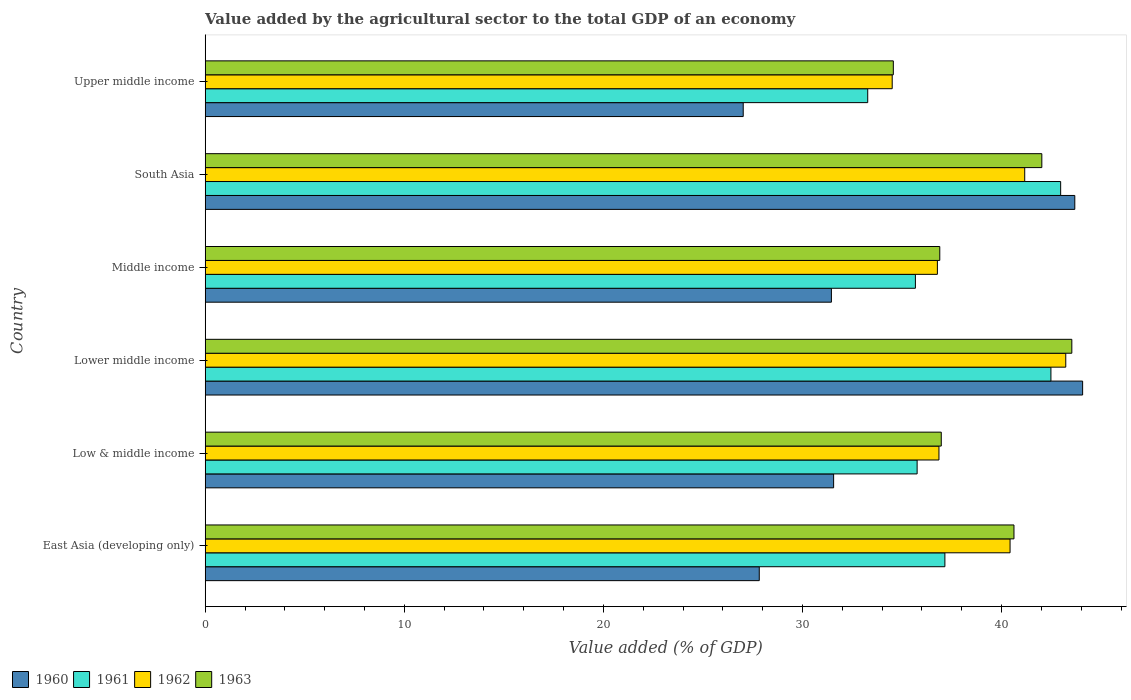How many groups of bars are there?
Ensure brevity in your answer.  6. Are the number of bars per tick equal to the number of legend labels?
Ensure brevity in your answer.  Yes. Are the number of bars on each tick of the Y-axis equal?
Provide a succinct answer. Yes. How many bars are there on the 5th tick from the top?
Make the answer very short. 4. How many bars are there on the 6th tick from the bottom?
Make the answer very short. 4. What is the label of the 3rd group of bars from the top?
Make the answer very short. Middle income. In how many cases, is the number of bars for a given country not equal to the number of legend labels?
Your response must be concise. 0. What is the value added by the agricultural sector to the total GDP in 1963 in Middle income?
Your answer should be compact. 36.89. Across all countries, what is the maximum value added by the agricultural sector to the total GDP in 1962?
Your answer should be compact. 43.22. Across all countries, what is the minimum value added by the agricultural sector to the total GDP in 1961?
Provide a short and direct response. 33.27. In which country was the value added by the agricultural sector to the total GDP in 1960 maximum?
Make the answer very short. Lower middle income. In which country was the value added by the agricultural sector to the total GDP in 1962 minimum?
Keep it short and to the point. Upper middle income. What is the total value added by the agricultural sector to the total GDP in 1962 in the graph?
Provide a succinct answer. 232.94. What is the difference between the value added by the agricultural sector to the total GDP in 1963 in Low & middle income and that in Lower middle income?
Provide a short and direct response. -6.56. What is the difference between the value added by the agricultural sector to the total GDP in 1961 in Upper middle income and the value added by the agricultural sector to the total GDP in 1960 in Low & middle income?
Give a very brief answer. 1.71. What is the average value added by the agricultural sector to the total GDP in 1963 per country?
Make the answer very short. 39.1. What is the difference between the value added by the agricultural sector to the total GDP in 1963 and value added by the agricultural sector to the total GDP in 1962 in Lower middle income?
Provide a short and direct response. 0.3. What is the ratio of the value added by the agricultural sector to the total GDP in 1962 in Low & middle income to that in Middle income?
Offer a very short reply. 1. Is the value added by the agricultural sector to the total GDP in 1960 in East Asia (developing only) less than that in Low & middle income?
Offer a very short reply. Yes. What is the difference between the highest and the second highest value added by the agricultural sector to the total GDP in 1962?
Give a very brief answer. 2.06. What is the difference between the highest and the lowest value added by the agricultural sector to the total GDP in 1961?
Offer a very short reply. 9.69. In how many countries, is the value added by the agricultural sector to the total GDP in 1961 greater than the average value added by the agricultural sector to the total GDP in 1961 taken over all countries?
Make the answer very short. 2. Is it the case that in every country, the sum of the value added by the agricultural sector to the total GDP in 1961 and value added by the agricultural sector to the total GDP in 1960 is greater than the value added by the agricultural sector to the total GDP in 1962?
Offer a very short reply. Yes. How many bars are there?
Offer a very short reply. 24. Does the graph contain grids?
Ensure brevity in your answer.  No. Where does the legend appear in the graph?
Make the answer very short. Bottom left. How are the legend labels stacked?
Ensure brevity in your answer.  Horizontal. What is the title of the graph?
Give a very brief answer. Value added by the agricultural sector to the total GDP of an economy. What is the label or title of the X-axis?
Provide a succinct answer. Value added (% of GDP). What is the Value added (% of GDP) in 1960 in East Asia (developing only)?
Offer a terse response. 27.83. What is the Value added (% of GDP) of 1961 in East Asia (developing only)?
Your answer should be very brief. 37.15. What is the Value added (% of GDP) in 1962 in East Asia (developing only)?
Ensure brevity in your answer.  40.42. What is the Value added (% of GDP) of 1963 in East Asia (developing only)?
Offer a very short reply. 40.62. What is the Value added (% of GDP) in 1960 in Low & middle income?
Your response must be concise. 31.56. What is the Value added (% of GDP) in 1961 in Low & middle income?
Make the answer very short. 35.76. What is the Value added (% of GDP) in 1962 in Low & middle income?
Keep it short and to the point. 36.85. What is the Value added (% of GDP) of 1963 in Low & middle income?
Keep it short and to the point. 36.97. What is the Value added (% of GDP) of 1960 in Lower middle income?
Provide a short and direct response. 44.07. What is the Value added (% of GDP) in 1961 in Lower middle income?
Provide a short and direct response. 42.48. What is the Value added (% of GDP) in 1962 in Lower middle income?
Provide a succinct answer. 43.22. What is the Value added (% of GDP) in 1963 in Lower middle income?
Your answer should be very brief. 43.53. What is the Value added (% of GDP) in 1960 in Middle income?
Provide a short and direct response. 31.45. What is the Value added (% of GDP) of 1961 in Middle income?
Make the answer very short. 35.67. What is the Value added (% of GDP) of 1962 in Middle income?
Provide a short and direct response. 36.77. What is the Value added (% of GDP) of 1963 in Middle income?
Make the answer very short. 36.89. What is the Value added (% of GDP) of 1960 in South Asia?
Provide a short and direct response. 43.68. What is the Value added (% of GDP) of 1961 in South Asia?
Make the answer very short. 42.96. What is the Value added (% of GDP) of 1962 in South Asia?
Your response must be concise. 41.16. What is the Value added (% of GDP) in 1963 in South Asia?
Keep it short and to the point. 42.02. What is the Value added (% of GDP) of 1960 in Upper middle income?
Your response must be concise. 27.02. What is the Value added (% of GDP) of 1961 in Upper middle income?
Provide a succinct answer. 33.27. What is the Value added (% of GDP) of 1962 in Upper middle income?
Make the answer very short. 34.5. What is the Value added (% of GDP) of 1963 in Upper middle income?
Provide a short and direct response. 34.56. Across all countries, what is the maximum Value added (% of GDP) of 1960?
Give a very brief answer. 44.07. Across all countries, what is the maximum Value added (% of GDP) of 1961?
Keep it short and to the point. 42.96. Across all countries, what is the maximum Value added (% of GDP) in 1962?
Your response must be concise. 43.22. Across all countries, what is the maximum Value added (% of GDP) in 1963?
Keep it short and to the point. 43.53. Across all countries, what is the minimum Value added (% of GDP) in 1960?
Offer a very short reply. 27.02. Across all countries, what is the minimum Value added (% of GDP) in 1961?
Make the answer very short. 33.27. Across all countries, what is the minimum Value added (% of GDP) of 1962?
Your answer should be very brief. 34.5. Across all countries, what is the minimum Value added (% of GDP) of 1963?
Make the answer very short. 34.56. What is the total Value added (% of GDP) of 1960 in the graph?
Provide a short and direct response. 205.61. What is the total Value added (% of GDP) in 1961 in the graph?
Your response must be concise. 227.29. What is the total Value added (% of GDP) of 1962 in the graph?
Give a very brief answer. 232.94. What is the total Value added (% of GDP) of 1963 in the graph?
Make the answer very short. 234.59. What is the difference between the Value added (% of GDP) in 1960 in East Asia (developing only) and that in Low & middle income?
Keep it short and to the point. -3.74. What is the difference between the Value added (% of GDP) of 1961 in East Asia (developing only) and that in Low & middle income?
Your response must be concise. 1.39. What is the difference between the Value added (% of GDP) in 1962 in East Asia (developing only) and that in Low & middle income?
Offer a very short reply. 3.57. What is the difference between the Value added (% of GDP) in 1963 in East Asia (developing only) and that in Low & middle income?
Ensure brevity in your answer.  3.65. What is the difference between the Value added (% of GDP) in 1960 in East Asia (developing only) and that in Lower middle income?
Your answer should be compact. -16.24. What is the difference between the Value added (% of GDP) in 1961 in East Asia (developing only) and that in Lower middle income?
Make the answer very short. -5.33. What is the difference between the Value added (% of GDP) in 1962 in East Asia (developing only) and that in Lower middle income?
Your response must be concise. -2.8. What is the difference between the Value added (% of GDP) in 1963 in East Asia (developing only) and that in Lower middle income?
Your answer should be compact. -2.91. What is the difference between the Value added (% of GDP) of 1960 in East Asia (developing only) and that in Middle income?
Your response must be concise. -3.62. What is the difference between the Value added (% of GDP) of 1961 in East Asia (developing only) and that in Middle income?
Provide a succinct answer. 1.48. What is the difference between the Value added (% of GDP) of 1962 in East Asia (developing only) and that in Middle income?
Offer a very short reply. 3.65. What is the difference between the Value added (% of GDP) in 1963 in East Asia (developing only) and that in Middle income?
Offer a terse response. 3.73. What is the difference between the Value added (% of GDP) of 1960 in East Asia (developing only) and that in South Asia?
Keep it short and to the point. -15.85. What is the difference between the Value added (% of GDP) of 1961 in East Asia (developing only) and that in South Asia?
Provide a short and direct response. -5.81. What is the difference between the Value added (% of GDP) in 1962 in East Asia (developing only) and that in South Asia?
Your response must be concise. -0.74. What is the difference between the Value added (% of GDP) in 1963 in East Asia (developing only) and that in South Asia?
Provide a succinct answer. -1.4. What is the difference between the Value added (% of GDP) in 1960 in East Asia (developing only) and that in Upper middle income?
Ensure brevity in your answer.  0.81. What is the difference between the Value added (% of GDP) of 1961 in East Asia (developing only) and that in Upper middle income?
Offer a terse response. 3.88. What is the difference between the Value added (% of GDP) in 1962 in East Asia (developing only) and that in Upper middle income?
Offer a very short reply. 5.92. What is the difference between the Value added (% of GDP) of 1963 in East Asia (developing only) and that in Upper middle income?
Offer a terse response. 6.06. What is the difference between the Value added (% of GDP) of 1960 in Low & middle income and that in Lower middle income?
Ensure brevity in your answer.  -12.51. What is the difference between the Value added (% of GDP) of 1961 in Low & middle income and that in Lower middle income?
Provide a short and direct response. -6.72. What is the difference between the Value added (% of GDP) of 1962 in Low & middle income and that in Lower middle income?
Offer a terse response. -6.37. What is the difference between the Value added (% of GDP) in 1963 in Low & middle income and that in Lower middle income?
Your answer should be very brief. -6.56. What is the difference between the Value added (% of GDP) in 1960 in Low & middle income and that in Middle income?
Give a very brief answer. 0.11. What is the difference between the Value added (% of GDP) of 1961 in Low & middle income and that in Middle income?
Keep it short and to the point. 0.09. What is the difference between the Value added (% of GDP) in 1962 in Low & middle income and that in Middle income?
Your response must be concise. 0.08. What is the difference between the Value added (% of GDP) in 1963 in Low & middle income and that in Middle income?
Your answer should be compact. 0.07. What is the difference between the Value added (% of GDP) of 1960 in Low & middle income and that in South Asia?
Keep it short and to the point. -12.11. What is the difference between the Value added (% of GDP) in 1961 in Low & middle income and that in South Asia?
Keep it short and to the point. -7.21. What is the difference between the Value added (% of GDP) of 1962 in Low & middle income and that in South Asia?
Offer a terse response. -4.31. What is the difference between the Value added (% of GDP) of 1963 in Low & middle income and that in South Asia?
Your answer should be very brief. -5.05. What is the difference between the Value added (% of GDP) of 1960 in Low & middle income and that in Upper middle income?
Give a very brief answer. 4.54. What is the difference between the Value added (% of GDP) of 1961 in Low & middle income and that in Upper middle income?
Keep it short and to the point. 2.48. What is the difference between the Value added (% of GDP) in 1962 in Low & middle income and that in Upper middle income?
Your answer should be compact. 2.35. What is the difference between the Value added (% of GDP) of 1963 in Low & middle income and that in Upper middle income?
Provide a short and direct response. 2.41. What is the difference between the Value added (% of GDP) of 1960 in Lower middle income and that in Middle income?
Give a very brief answer. 12.62. What is the difference between the Value added (% of GDP) of 1961 in Lower middle income and that in Middle income?
Ensure brevity in your answer.  6.81. What is the difference between the Value added (% of GDP) in 1962 in Lower middle income and that in Middle income?
Offer a terse response. 6.45. What is the difference between the Value added (% of GDP) of 1963 in Lower middle income and that in Middle income?
Give a very brief answer. 6.63. What is the difference between the Value added (% of GDP) in 1960 in Lower middle income and that in South Asia?
Make the answer very short. 0.39. What is the difference between the Value added (% of GDP) in 1961 in Lower middle income and that in South Asia?
Give a very brief answer. -0.49. What is the difference between the Value added (% of GDP) in 1962 in Lower middle income and that in South Asia?
Offer a very short reply. 2.06. What is the difference between the Value added (% of GDP) in 1963 in Lower middle income and that in South Asia?
Give a very brief answer. 1.51. What is the difference between the Value added (% of GDP) of 1960 in Lower middle income and that in Upper middle income?
Offer a terse response. 17.05. What is the difference between the Value added (% of GDP) of 1961 in Lower middle income and that in Upper middle income?
Your response must be concise. 9.2. What is the difference between the Value added (% of GDP) in 1962 in Lower middle income and that in Upper middle income?
Provide a short and direct response. 8.72. What is the difference between the Value added (% of GDP) in 1963 in Lower middle income and that in Upper middle income?
Keep it short and to the point. 8.97. What is the difference between the Value added (% of GDP) of 1960 in Middle income and that in South Asia?
Your answer should be compact. -12.22. What is the difference between the Value added (% of GDP) of 1961 in Middle income and that in South Asia?
Keep it short and to the point. -7.29. What is the difference between the Value added (% of GDP) in 1962 in Middle income and that in South Asia?
Your answer should be very brief. -4.39. What is the difference between the Value added (% of GDP) of 1963 in Middle income and that in South Asia?
Offer a terse response. -5.13. What is the difference between the Value added (% of GDP) of 1960 in Middle income and that in Upper middle income?
Offer a very short reply. 4.43. What is the difference between the Value added (% of GDP) in 1961 in Middle income and that in Upper middle income?
Your answer should be compact. 2.4. What is the difference between the Value added (% of GDP) in 1962 in Middle income and that in Upper middle income?
Your answer should be very brief. 2.27. What is the difference between the Value added (% of GDP) in 1963 in Middle income and that in Upper middle income?
Your answer should be very brief. 2.33. What is the difference between the Value added (% of GDP) in 1960 in South Asia and that in Upper middle income?
Ensure brevity in your answer.  16.65. What is the difference between the Value added (% of GDP) in 1961 in South Asia and that in Upper middle income?
Your answer should be very brief. 9.69. What is the difference between the Value added (% of GDP) in 1962 in South Asia and that in Upper middle income?
Provide a succinct answer. 6.66. What is the difference between the Value added (% of GDP) of 1963 in South Asia and that in Upper middle income?
Offer a terse response. 7.46. What is the difference between the Value added (% of GDP) in 1960 in East Asia (developing only) and the Value added (% of GDP) in 1961 in Low & middle income?
Keep it short and to the point. -7.93. What is the difference between the Value added (% of GDP) of 1960 in East Asia (developing only) and the Value added (% of GDP) of 1962 in Low & middle income?
Give a very brief answer. -9.02. What is the difference between the Value added (% of GDP) in 1960 in East Asia (developing only) and the Value added (% of GDP) in 1963 in Low & middle income?
Give a very brief answer. -9.14. What is the difference between the Value added (% of GDP) in 1961 in East Asia (developing only) and the Value added (% of GDP) in 1962 in Low & middle income?
Your answer should be compact. 0.3. What is the difference between the Value added (% of GDP) of 1961 in East Asia (developing only) and the Value added (% of GDP) of 1963 in Low & middle income?
Keep it short and to the point. 0.18. What is the difference between the Value added (% of GDP) of 1962 in East Asia (developing only) and the Value added (% of GDP) of 1963 in Low & middle income?
Provide a succinct answer. 3.46. What is the difference between the Value added (% of GDP) of 1960 in East Asia (developing only) and the Value added (% of GDP) of 1961 in Lower middle income?
Make the answer very short. -14.65. What is the difference between the Value added (% of GDP) in 1960 in East Asia (developing only) and the Value added (% of GDP) in 1962 in Lower middle income?
Give a very brief answer. -15.39. What is the difference between the Value added (% of GDP) in 1960 in East Asia (developing only) and the Value added (% of GDP) in 1963 in Lower middle income?
Keep it short and to the point. -15.7. What is the difference between the Value added (% of GDP) in 1961 in East Asia (developing only) and the Value added (% of GDP) in 1962 in Lower middle income?
Keep it short and to the point. -6.07. What is the difference between the Value added (% of GDP) in 1961 in East Asia (developing only) and the Value added (% of GDP) in 1963 in Lower middle income?
Offer a terse response. -6.38. What is the difference between the Value added (% of GDP) in 1962 in East Asia (developing only) and the Value added (% of GDP) in 1963 in Lower middle income?
Offer a very short reply. -3.1. What is the difference between the Value added (% of GDP) of 1960 in East Asia (developing only) and the Value added (% of GDP) of 1961 in Middle income?
Provide a succinct answer. -7.84. What is the difference between the Value added (% of GDP) in 1960 in East Asia (developing only) and the Value added (% of GDP) in 1962 in Middle income?
Provide a succinct answer. -8.95. What is the difference between the Value added (% of GDP) in 1960 in East Asia (developing only) and the Value added (% of GDP) in 1963 in Middle income?
Your answer should be very brief. -9.07. What is the difference between the Value added (% of GDP) in 1961 in East Asia (developing only) and the Value added (% of GDP) in 1962 in Middle income?
Provide a short and direct response. 0.38. What is the difference between the Value added (% of GDP) of 1961 in East Asia (developing only) and the Value added (% of GDP) of 1963 in Middle income?
Provide a succinct answer. 0.26. What is the difference between the Value added (% of GDP) of 1962 in East Asia (developing only) and the Value added (% of GDP) of 1963 in Middle income?
Your answer should be compact. 3.53. What is the difference between the Value added (% of GDP) of 1960 in East Asia (developing only) and the Value added (% of GDP) of 1961 in South Asia?
Your answer should be compact. -15.14. What is the difference between the Value added (% of GDP) of 1960 in East Asia (developing only) and the Value added (% of GDP) of 1962 in South Asia?
Your response must be concise. -13.33. What is the difference between the Value added (% of GDP) of 1960 in East Asia (developing only) and the Value added (% of GDP) of 1963 in South Asia?
Your answer should be very brief. -14.19. What is the difference between the Value added (% of GDP) in 1961 in East Asia (developing only) and the Value added (% of GDP) in 1962 in South Asia?
Your answer should be very brief. -4.01. What is the difference between the Value added (% of GDP) of 1961 in East Asia (developing only) and the Value added (% of GDP) of 1963 in South Asia?
Make the answer very short. -4.87. What is the difference between the Value added (% of GDP) in 1962 in East Asia (developing only) and the Value added (% of GDP) in 1963 in South Asia?
Your answer should be compact. -1.6. What is the difference between the Value added (% of GDP) in 1960 in East Asia (developing only) and the Value added (% of GDP) in 1961 in Upper middle income?
Keep it short and to the point. -5.45. What is the difference between the Value added (% of GDP) in 1960 in East Asia (developing only) and the Value added (% of GDP) in 1962 in Upper middle income?
Offer a very short reply. -6.68. What is the difference between the Value added (% of GDP) of 1960 in East Asia (developing only) and the Value added (% of GDP) of 1963 in Upper middle income?
Offer a very short reply. -6.73. What is the difference between the Value added (% of GDP) of 1961 in East Asia (developing only) and the Value added (% of GDP) of 1962 in Upper middle income?
Offer a terse response. 2.65. What is the difference between the Value added (% of GDP) of 1961 in East Asia (developing only) and the Value added (% of GDP) of 1963 in Upper middle income?
Offer a terse response. 2.59. What is the difference between the Value added (% of GDP) in 1962 in East Asia (developing only) and the Value added (% of GDP) in 1963 in Upper middle income?
Make the answer very short. 5.86. What is the difference between the Value added (% of GDP) in 1960 in Low & middle income and the Value added (% of GDP) in 1961 in Lower middle income?
Offer a very short reply. -10.91. What is the difference between the Value added (% of GDP) in 1960 in Low & middle income and the Value added (% of GDP) in 1962 in Lower middle income?
Give a very brief answer. -11.66. What is the difference between the Value added (% of GDP) of 1960 in Low & middle income and the Value added (% of GDP) of 1963 in Lower middle income?
Offer a very short reply. -11.96. What is the difference between the Value added (% of GDP) in 1961 in Low & middle income and the Value added (% of GDP) in 1962 in Lower middle income?
Your response must be concise. -7.47. What is the difference between the Value added (% of GDP) in 1961 in Low & middle income and the Value added (% of GDP) in 1963 in Lower middle income?
Provide a short and direct response. -7.77. What is the difference between the Value added (% of GDP) of 1962 in Low & middle income and the Value added (% of GDP) of 1963 in Lower middle income?
Provide a short and direct response. -6.67. What is the difference between the Value added (% of GDP) of 1960 in Low & middle income and the Value added (% of GDP) of 1961 in Middle income?
Your answer should be very brief. -4.11. What is the difference between the Value added (% of GDP) in 1960 in Low & middle income and the Value added (% of GDP) in 1962 in Middle income?
Provide a succinct answer. -5.21. What is the difference between the Value added (% of GDP) in 1960 in Low & middle income and the Value added (% of GDP) in 1963 in Middle income?
Your answer should be compact. -5.33. What is the difference between the Value added (% of GDP) in 1961 in Low & middle income and the Value added (% of GDP) in 1962 in Middle income?
Keep it short and to the point. -1.02. What is the difference between the Value added (% of GDP) of 1961 in Low & middle income and the Value added (% of GDP) of 1963 in Middle income?
Offer a terse response. -1.14. What is the difference between the Value added (% of GDP) of 1962 in Low & middle income and the Value added (% of GDP) of 1963 in Middle income?
Your answer should be very brief. -0.04. What is the difference between the Value added (% of GDP) in 1960 in Low & middle income and the Value added (% of GDP) in 1961 in South Asia?
Provide a succinct answer. -11.4. What is the difference between the Value added (% of GDP) in 1960 in Low & middle income and the Value added (% of GDP) in 1962 in South Asia?
Your answer should be very brief. -9.6. What is the difference between the Value added (% of GDP) of 1960 in Low & middle income and the Value added (% of GDP) of 1963 in South Asia?
Offer a terse response. -10.46. What is the difference between the Value added (% of GDP) of 1961 in Low & middle income and the Value added (% of GDP) of 1962 in South Asia?
Make the answer very short. -5.4. What is the difference between the Value added (% of GDP) in 1961 in Low & middle income and the Value added (% of GDP) in 1963 in South Asia?
Provide a succinct answer. -6.26. What is the difference between the Value added (% of GDP) of 1962 in Low & middle income and the Value added (% of GDP) of 1963 in South Asia?
Give a very brief answer. -5.17. What is the difference between the Value added (% of GDP) of 1960 in Low & middle income and the Value added (% of GDP) of 1961 in Upper middle income?
Offer a terse response. -1.71. What is the difference between the Value added (% of GDP) of 1960 in Low & middle income and the Value added (% of GDP) of 1962 in Upper middle income?
Your answer should be compact. -2.94. What is the difference between the Value added (% of GDP) in 1960 in Low & middle income and the Value added (% of GDP) in 1963 in Upper middle income?
Provide a succinct answer. -3. What is the difference between the Value added (% of GDP) in 1961 in Low & middle income and the Value added (% of GDP) in 1962 in Upper middle income?
Provide a succinct answer. 1.25. What is the difference between the Value added (% of GDP) in 1961 in Low & middle income and the Value added (% of GDP) in 1963 in Upper middle income?
Keep it short and to the point. 1.2. What is the difference between the Value added (% of GDP) of 1962 in Low & middle income and the Value added (% of GDP) of 1963 in Upper middle income?
Your answer should be compact. 2.29. What is the difference between the Value added (% of GDP) of 1960 in Lower middle income and the Value added (% of GDP) of 1961 in Middle income?
Ensure brevity in your answer.  8.4. What is the difference between the Value added (% of GDP) in 1960 in Lower middle income and the Value added (% of GDP) in 1962 in Middle income?
Your answer should be very brief. 7.29. What is the difference between the Value added (% of GDP) of 1960 in Lower middle income and the Value added (% of GDP) of 1963 in Middle income?
Give a very brief answer. 7.17. What is the difference between the Value added (% of GDP) of 1961 in Lower middle income and the Value added (% of GDP) of 1962 in Middle income?
Offer a terse response. 5.7. What is the difference between the Value added (% of GDP) in 1961 in Lower middle income and the Value added (% of GDP) in 1963 in Middle income?
Your response must be concise. 5.58. What is the difference between the Value added (% of GDP) in 1962 in Lower middle income and the Value added (% of GDP) in 1963 in Middle income?
Make the answer very short. 6.33. What is the difference between the Value added (% of GDP) in 1960 in Lower middle income and the Value added (% of GDP) in 1961 in South Asia?
Your response must be concise. 1.1. What is the difference between the Value added (% of GDP) of 1960 in Lower middle income and the Value added (% of GDP) of 1962 in South Asia?
Offer a terse response. 2.91. What is the difference between the Value added (% of GDP) of 1960 in Lower middle income and the Value added (% of GDP) of 1963 in South Asia?
Ensure brevity in your answer.  2.05. What is the difference between the Value added (% of GDP) in 1961 in Lower middle income and the Value added (% of GDP) in 1962 in South Asia?
Your answer should be compact. 1.32. What is the difference between the Value added (% of GDP) of 1961 in Lower middle income and the Value added (% of GDP) of 1963 in South Asia?
Provide a succinct answer. 0.46. What is the difference between the Value added (% of GDP) in 1962 in Lower middle income and the Value added (% of GDP) in 1963 in South Asia?
Offer a terse response. 1.2. What is the difference between the Value added (% of GDP) in 1960 in Lower middle income and the Value added (% of GDP) in 1961 in Upper middle income?
Make the answer very short. 10.79. What is the difference between the Value added (% of GDP) in 1960 in Lower middle income and the Value added (% of GDP) in 1962 in Upper middle income?
Give a very brief answer. 9.56. What is the difference between the Value added (% of GDP) of 1960 in Lower middle income and the Value added (% of GDP) of 1963 in Upper middle income?
Make the answer very short. 9.51. What is the difference between the Value added (% of GDP) in 1961 in Lower middle income and the Value added (% of GDP) in 1962 in Upper middle income?
Keep it short and to the point. 7.97. What is the difference between the Value added (% of GDP) in 1961 in Lower middle income and the Value added (% of GDP) in 1963 in Upper middle income?
Ensure brevity in your answer.  7.92. What is the difference between the Value added (% of GDP) of 1962 in Lower middle income and the Value added (% of GDP) of 1963 in Upper middle income?
Offer a terse response. 8.66. What is the difference between the Value added (% of GDP) of 1960 in Middle income and the Value added (% of GDP) of 1961 in South Asia?
Offer a very short reply. -11.51. What is the difference between the Value added (% of GDP) of 1960 in Middle income and the Value added (% of GDP) of 1962 in South Asia?
Give a very brief answer. -9.71. What is the difference between the Value added (% of GDP) of 1960 in Middle income and the Value added (% of GDP) of 1963 in South Asia?
Your answer should be very brief. -10.57. What is the difference between the Value added (% of GDP) of 1961 in Middle income and the Value added (% of GDP) of 1962 in South Asia?
Ensure brevity in your answer.  -5.49. What is the difference between the Value added (% of GDP) of 1961 in Middle income and the Value added (% of GDP) of 1963 in South Asia?
Your answer should be very brief. -6.35. What is the difference between the Value added (% of GDP) in 1962 in Middle income and the Value added (% of GDP) in 1963 in South Asia?
Give a very brief answer. -5.25. What is the difference between the Value added (% of GDP) in 1960 in Middle income and the Value added (% of GDP) in 1961 in Upper middle income?
Ensure brevity in your answer.  -1.82. What is the difference between the Value added (% of GDP) in 1960 in Middle income and the Value added (% of GDP) in 1962 in Upper middle income?
Your response must be concise. -3.05. What is the difference between the Value added (% of GDP) in 1960 in Middle income and the Value added (% of GDP) in 1963 in Upper middle income?
Keep it short and to the point. -3.11. What is the difference between the Value added (% of GDP) of 1961 in Middle income and the Value added (% of GDP) of 1962 in Upper middle income?
Your answer should be very brief. 1.17. What is the difference between the Value added (% of GDP) of 1961 in Middle income and the Value added (% of GDP) of 1963 in Upper middle income?
Give a very brief answer. 1.11. What is the difference between the Value added (% of GDP) of 1962 in Middle income and the Value added (% of GDP) of 1963 in Upper middle income?
Offer a very short reply. 2.21. What is the difference between the Value added (% of GDP) of 1960 in South Asia and the Value added (% of GDP) of 1961 in Upper middle income?
Your answer should be very brief. 10.4. What is the difference between the Value added (% of GDP) in 1960 in South Asia and the Value added (% of GDP) in 1962 in Upper middle income?
Ensure brevity in your answer.  9.17. What is the difference between the Value added (% of GDP) in 1960 in South Asia and the Value added (% of GDP) in 1963 in Upper middle income?
Keep it short and to the point. 9.11. What is the difference between the Value added (% of GDP) in 1961 in South Asia and the Value added (% of GDP) in 1962 in Upper middle income?
Keep it short and to the point. 8.46. What is the difference between the Value added (% of GDP) of 1961 in South Asia and the Value added (% of GDP) of 1963 in Upper middle income?
Your answer should be very brief. 8.4. What is the difference between the Value added (% of GDP) in 1962 in South Asia and the Value added (% of GDP) in 1963 in Upper middle income?
Offer a terse response. 6.6. What is the average Value added (% of GDP) in 1960 per country?
Provide a short and direct response. 34.27. What is the average Value added (% of GDP) in 1961 per country?
Ensure brevity in your answer.  37.88. What is the average Value added (% of GDP) in 1962 per country?
Your answer should be compact. 38.82. What is the average Value added (% of GDP) in 1963 per country?
Keep it short and to the point. 39.1. What is the difference between the Value added (% of GDP) of 1960 and Value added (% of GDP) of 1961 in East Asia (developing only)?
Offer a terse response. -9.32. What is the difference between the Value added (% of GDP) in 1960 and Value added (% of GDP) in 1962 in East Asia (developing only)?
Offer a very short reply. -12.6. What is the difference between the Value added (% of GDP) of 1960 and Value added (% of GDP) of 1963 in East Asia (developing only)?
Provide a short and direct response. -12.79. What is the difference between the Value added (% of GDP) of 1961 and Value added (% of GDP) of 1962 in East Asia (developing only)?
Ensure brevity in your answer.  -3.27. What is the difference between the Value added (% of GDP) in 1961 and Value added (% of GDP) in 1963 in East Asia (developing only)?
Give a very brief answer. -3.47. What is the difference between the Value added (% of GDP) in 1962 and Value added (% of GDP) in 1963 in East Asia (developing only)?
Your answer should be very brief. -0.2. What is the difference between the Value added (% of GDP) of 1960 and Value added (% of GDP) of 1961 in Low & middle income?
Provide a succinct answer. -4.19. What is the difference between the Value added (% of GDP) of 1960 and Value added (% of GDP) of 1962 in Low & middle income?
Ensure brevity in your answer.  -5.29. What is the difference between the Value added (% of GDP) of 1960 and Value added (% of GDP) of 1963 in Low & middle income?
Your answer should be very brief. -5.41. What is the difference between the Value added (% of GDP) in 1961 and Value added (% of GDP) in 1962 in Low & middle income?
Your answer should be compact. -1.1. What is the difference between the Value added (% of GDP) in 1961 and Value added (% of GDP) in 1963 in Low & middle income?
Ensure brevity in your answer.  -1.21. What is the difference between the Value added (% of GDP) of 1962 and Value added (% of GDP) of 1963 in Low & middle income?
Provide a succinct answer. -0.12. What is the difference between the Value added (% of GDP) of 1960 and Value added (% of GDP) of 1961 in Lower middle income?
Give a very brief answer. 1.59. What is the difference between the Value added (% of GDP) of 1960 and Value added (% of GDP) of 1962 in Lower middle income?
Offer a very short reply. 0.85. What is the difference between the Value added (% of GDP) of 1960 and Value added (% of GDP) of 1963 in Lower middle income?
Ensure brevity in your answer.  0.54. What is the difference between the Value added (% of GDP) in 1961 and Value added (% of GDP) in 1962 in Lower middle income?
Your answer should be compact. -0.75. What is the difference between the Value added (% of GDP) in 1961 and Value added (% of GDP) in 1963 in Lower middle income?
Ensure brevity in your answer.  -1.05. What is the difference between the Value added (% of GDP) in 1962 and Value added (% of GDP) in 1963 in Lower middle income?
Your response must be concise. -0.3. What is the difference between the Value added (% of GDP) of 1960 and Value added (% of GDP) of 1961 in Middle income?
Ensure brevity in your answer.  -4.22. What is the difference between the Value added (% of GDP) of 1960 and Value added (% of GDP) of 1962 in Middle income?
Keep it short and to the point. -5.32. What is the difference between the Value added (% of GDP) of 1960 and Value added (% of GDP) of 1963 in Middle income?
Your response must be concise. -5.44. What is the difference between the Value added (% of GDP) of 1961 and Value added (% of GDP) of 1962 in Middle income?
Your answer should be compact. -1.1. What is the difference between the Value added (% of GDP) of 1961 and Value added (% of GDP) of 1963 in Middle income?
Make the answer very short. -1.22. What is the difference between the Value added (% of GDP) in 1962 and Value added (% of GDP) in 1963 in Middle income?
Keep it short and to the point. -0.12. What is the difference between the Value added (% of GDP) of 1960 and Value added (% of GDP) of 1961 in South Asia?
Keep it short and to the point. 0.71. What is the difference between the Value added (% of GDP) of 1960 and Value added (% of GDP) of 1962 in South Asia?
Give a very brief answer. 2.52. What is the difference between the Value added (% of GDP) of 1960 and Value added (% of GDP) of 1963 in South Asia?
Your answer should be very brief. 1.66. What is the difference between the Value added (% of GDP) of 1961 and Value added (% of GDP) of 1962 in South Asia?
Offer a terse response. 1.8. What is the difference between the Value added (% of GDP) in 1961 and Value added (% of GDP) in 1963 in South Asia?
Your answer should be very brief. 0.95. What is the difference between the Value added (% of GDP) of 1962 and Value added (% of GDP) of 1963 in South Asia?
Offer a very short reply. -0.86. What is the difference between the Value added (% of GDP) of 1960 and Value added (% of GDP) of 1961 in Upper middle income?
Offer a very short reply. -6.25. What is the difference between the Value added (% of GDP) of 1960 and Value added (% of GDP) of 1962 in Upper middle income?
Offer a terse response. -7.48. What is the difference between the Value added (% of GDP) of 1960 and Value added (% of GDP) of 1963 in Upper middle income?
Keep it short and to the point. -7.54. What is the difference between the Value added (% of GDP) of 1961 and Value added (% of GDP) of 1962 in Upper middle income?
Provide a short and direct response. -1.23. What is the difference between the Value added (% of GDP) of 1961 and Value added (% of GDP) of 1963 in Upper middle income?
Keep it short and to the point. -1.29. What is the difference between the Value added (% of GDP) in 1962 and Value added (% of GDP) in 1963 in Upper middle income?
Offer a terse response. -0.06. What is the ratio of the Value added (% of GDP) of 1960 in East Asia (developing only) to that in Low & middle income?
Ensure brevity in your answer.  0.88. What is the ratio of the Value added (% of GDP) of 1961 in East Asia (developing only) to that in Low & middle income?
Your answer should be very brief. 1.04. What is the ratio of the Value added (% of GDP) in 1962 in East Asia (developing only) to that in Low & middle income?
Provide a short and direct response. 1.1. What is the ratio of the Value added (% of GDP) in 1963 in East Asia (developing only) to that in Low & middle income?
Keep it short and to the point. 1.1. What is the ratio of the Value added (% of GDP) in 1960 in East Asia (developing only) to that in Lower middle income?
Ensure brevity in your answer.  0.63. What is the ratio of the Value added (% of GDP) in 1961 in East Asia (developing only) to that in Lower middle income?
Provide a succinct answer. 0.87. What is the ratio of the Value added (% of GDP) of 1962 in East Asia (developing only) to that in Lower middle income?
Offer a terse response. 0.94. What is the ratio of the Value added (% of GDP) of 1963 in East Asia (developing only) to that in Lower middle income?
Your answer should be very brief. 0.93. What is the ratio of the Value added (% of GDP) of 1960 in East Asia (developing only) to that in Middle income?
Give a very brief answer. 0.88. What is the ratio of the Value added (% of GDP) of 1961 in East Asia (developing only) to that in Middle income?
Offer a terse response. 1.04. What is the ratio of the Value added (% of GDP) of 1962 in East Asia (developing only) to that in Middle income?
Offer a very short reply. 1.1. What is the ratio of the Value added (% of GDP) of 1963 in East Asia (developing only) to that in Middle income?
Provide a succinct answer. 1.1. What is the ratio of the Value added (% of GDP) of 1960 in East Asia (developing only) to that in South Asia?
Offer a very short reply. 0.64. What is the ratio of the Value added (% of GDP) of 1961 in East Asia (developing only) to that in South Asia?
Give a very brief answer. 0.86. What is the ratio of the Value added (% of GDP) in 1962 in East Asia (developing only) to that in South Asia?
Ensure brevity in your answer.  0.98. What is the ratio of the Value added (% of GDP) of 1963 in East Asia (developing only) to that in South Asia?
Offer a very short reply. 0.97. What is the ratio of the Value added (% of GDP) in 1960 in East Asia (developing only) to that in Upper middle income?
Keep it short and to the point. 1.03. What is the ratio of the Value added (% of GDP) of 1961 in East Asia (developing only) to that in Upper middle income?
Make the answer very short. 1.12. What is the ratio of the Value added (% of GDP) in 1962 in East Asia (developing only) to that in Upper middle income?
Provide a short and direct response. 1.17. What is the ratio of the Value added (% of GDP) in 1963 in East Asia (developing only) to that in Upper middle income?
Provide a succinct answer. 1.18. What is the ratio of the Value added (% of GDP) of 1960 in Low & middle income to that in Lower middle income?
Keep it short and to the point. 0.72. What is the ratio of the Value added (% of GDP) of 1961 in Low & middle income to that in Lower middle income?
Ensure brevity in your answer.  0.84. What is the ratio of the Value added (% of GDP) in 1962 in Low & middle income to that in Lower middle income?
Your answer should be very brief. 0.85. What is the ratio of the Value added (% of GDP) of 1963 in Low & middle income to that in Lower middle income?
Offer a very short reply. 0.85. What is the ratio of the Value added (% of GDP) in 1961 in Low & middle income to that in Middle income?
Make the answer very short. 1. What is the ratio of the Value added (% of GDP) of 1962 in Low & middle income to that in Middle income?
Offer a very short reply. 1. What is the ratio of the Value added (% of GDP) of 1960 in Low & middle income to that in South Asia?
Keep it short and to the point. 0.72. What is the ratio of the Value added (% of GDP) in 1961 in Low & middle income to that in South Asia?
Make the answer very short. 0.83. What is the ratio of the Value added (% of GDP) of 1962 in Low & middle income to that in South Asia?
Offer a very short reply. 0.9. What is the ratio of the Value added (% of GDP) in 1963 in Low & middle income to that in South Asia?
Your answer should be compact. 0.88. What is the ratio of the Value added (% of GDP) in 1960 in Low & middle income to that in Upper middle income?
Your answer should be compact. 1.17. What is the ratio of the Value added (% of GDP) of 1961 in Low & middle income to that in Upper middle income?
Offer a very short reply. 1.07. What is the ratio of the Value added (% of GDP) of 1962 in Low & middle income to that in Upper middle income?
Provide a succinct answer. 1.07. What is the ratio of the Value added (% of GDP) of 1963 in Low & middle income to that in Upper middle income?
Keep it short and to the point. 1.07. What is the ratio of the Value added (% of GDP) in 1960 in Lower middle income to that in Middle income?
Your response must be concise. 1.4. What is the ratio of the Value added (% of GDP) in 1961 in Lower middle income to that in Middle income?
Provide a short and direct response. 1.19. What is the ratio of the Value added (% of GDP) in 1962 in Lower middle income to that in Middle income?
Give a very brief answer. 1.18. What is the ratio of the Value added (% of GDP) of 1963 in Lower middle income to that in Middle income?
Your answer should be very brief. 1.18. What is the ratio of the Value added (% of GDP) in 1960 in Lower middle income to that in South Asia?
Provide a succinct answer. 1.01. What is the ratio of the Value added (% of GDP) in 1962 in Lower middle income to that in South Asia?
Give a very brief answer. 1.05. What is the ratio of the Value added (% of GDP) in 1963 in Lower middle income to that in South Asia?
Your answer should be very brief. 1.04. What is the ratio of the Value added (% of GDP) in 1960 in Lower middle income to that in Upper middle income?
Ensure brevity in your answer.  1.63. What is the ratio of the Value added (% of GDP) of 1961 in Lower middle income to that in Upper middle income?
Offer a very short reply. 1.28. What is the ratio of the Value added (% of GDP) of 1962 in Lower middle income to that in Upper middle income?
Your answer should be very brief. 1.25. What is the ratio of the Value added (% of GDP) of 1963 in Lower middle income to that in Upper middle income?
Ensure brevity in your answer.  1.26. What is the ratio of the Value added (% of GDP) in 1960 in Middle income to that in South Asia?
Ensure brevity in your answer.  0.72. What is the ratio of the Value added (% of GDP) in 1961 in Middle income to that in South Asia?
Offer a very short reply. 0.83. What is the ratio of the Value added (% of GDP) of 1962 in Middle income to that in South Asia?
Ensure brevity in your answer.  0.89. What is the ratio of the Value added (% of GDP) in 1963 in Middle income to that in South Asia?
Offer a terse response. 0.88. What is the ratio of the Value added (% of GDP) in 1960 in Middle income to that in Upper middle income?
Offer a terse response. 1.16. What is the ratio of the Value added (% of GDP) of 1961 in Middle income to that in Upper middle income?
Keep it short and to the point. 1.07. What is the ratio of the Value added (% of GDP) in 1962 in Middle income to that in Upper middle income?
Ensure brevity in your answer.  1.07. What is the ratio of the Value added (% of GDP) of 1963 in Middle income to that in Upper middle income?
Provide a short and direct response. 1.07. What is the ratio of the Value added (% of GDP) of 1960 in South Asia to that in Upper middle income?
Provide a short and direct response. 1.62. What is the ratio of the Value added (% of GDP) in 1961 in South Asia to that in Upper middle income?
Make the answer very short. 1.29. What is the ratio of the Value added (% of GDP) in 1962 in South Asia to that in Upper middle income?
Your response must be concise. 1.19. What is the ratio of the Value added (% of GDP) in 1963 in South Asia to that in Upper middle income?
Offer a very short reply. 1.22. What is the difference between the highest and the second highest Value added (% of GDP) of 1960?
Your answer should be compact. 0.39. What is the difference between the highest and the second highest Value added (% of GDP) of 1961?
Keep it short and to the point. 0.49. What is the difference between the highest and the second highest Value added (% of GDP) of 1962?
Offer a very short reply. 2.06. What is the difference between the highest and the second highest Value added (% of GDP) in 1963?
Your answer should be compact. 1.51. What is the difference between the highest and the lowest Value added (% of GDP) of 1960?
Your answer should be very brief. 17.05. What is the difference between the highest and the lowest Value added (% of GDP) in 1961?
Your answer should be very brief. 9.69. What is the difference between the highest and the lowest Value added (% of GDP) of 1962?
Offer a terse response. 8.72. What is the difference between the highest and the lowest Value added (% of GDP) in 1963?
Your answer should be compact. 8.97. 